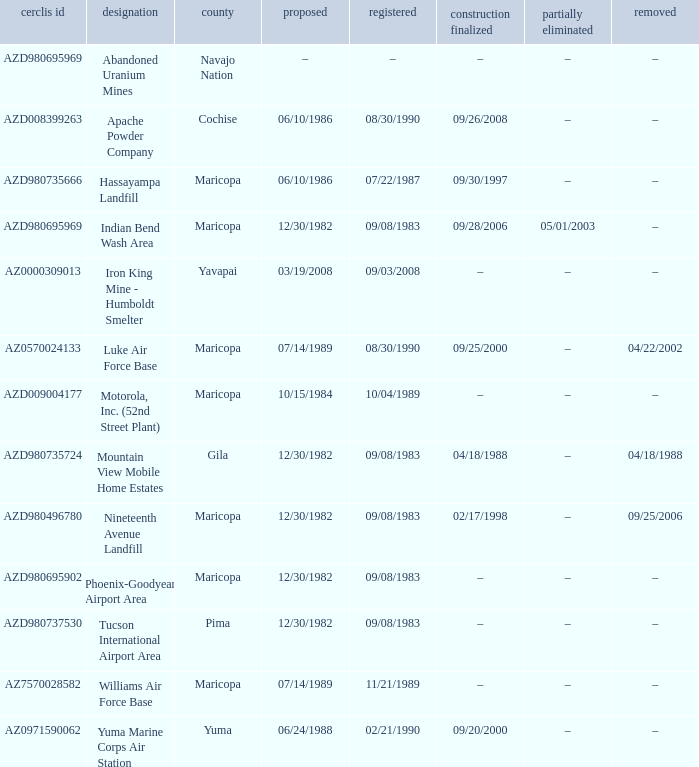What is the cerclis id when the site was proposed on 12/30/1982 and was partially deleted on 05/01/2003? AZD980695969. 